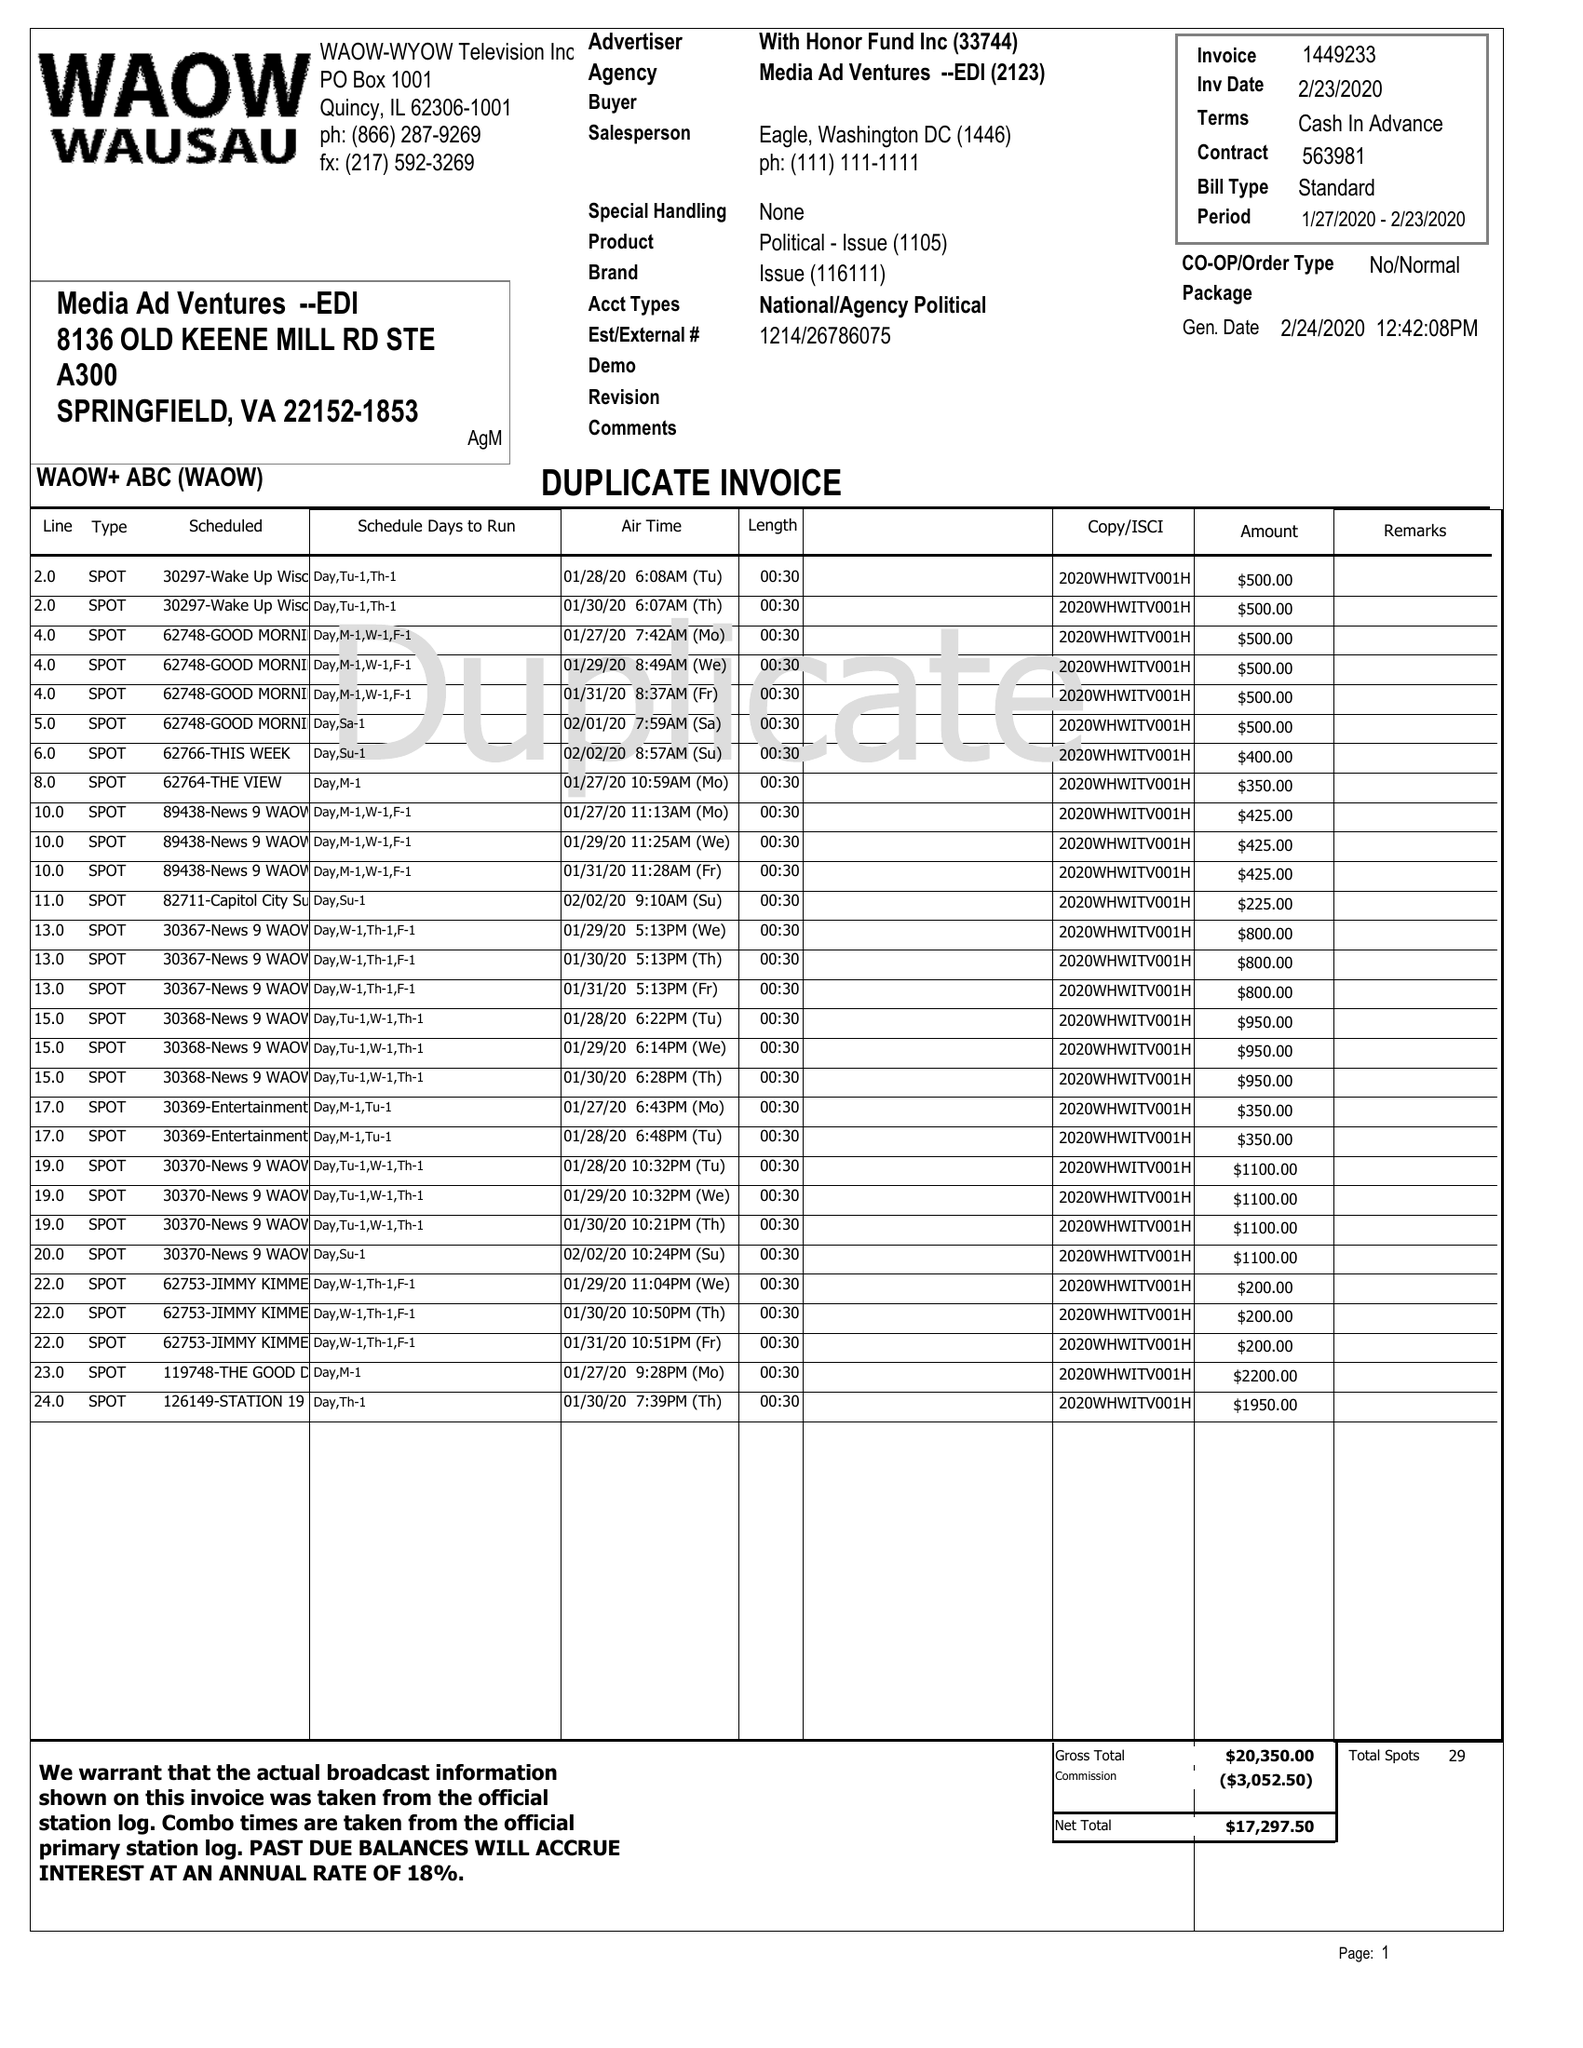What is the value for the flight_from?
Answer the question using a single word or phrase. 01/27/20 